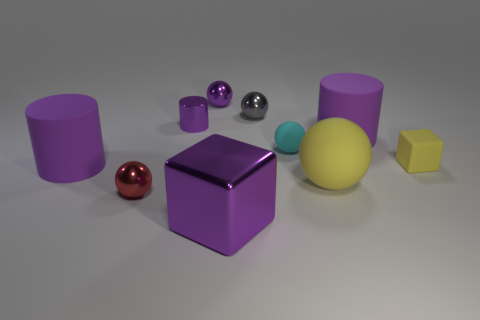How many purple cylinders must be subtracted to get 1 purple cylinders? 2 Subtract all gray spheres. How many spheres are left? 4 Subtract all small purple balls. How many balls are left? 4 Subtract all gray balls. Subtract all green blocks. How many balls are left? 4 Subtract all cubes. How many objects are left? 8 Add 1 purple matte things. How many purple matte things exist? 3 Subtract 0 green spheres. How many objects are left? 10 Subtract all red balls. Subtract all tiny purple metal cylinders. How many objects are left? 8 Add 5 small yellow rubber objects. How many small yellow rubber objects are left? 6 